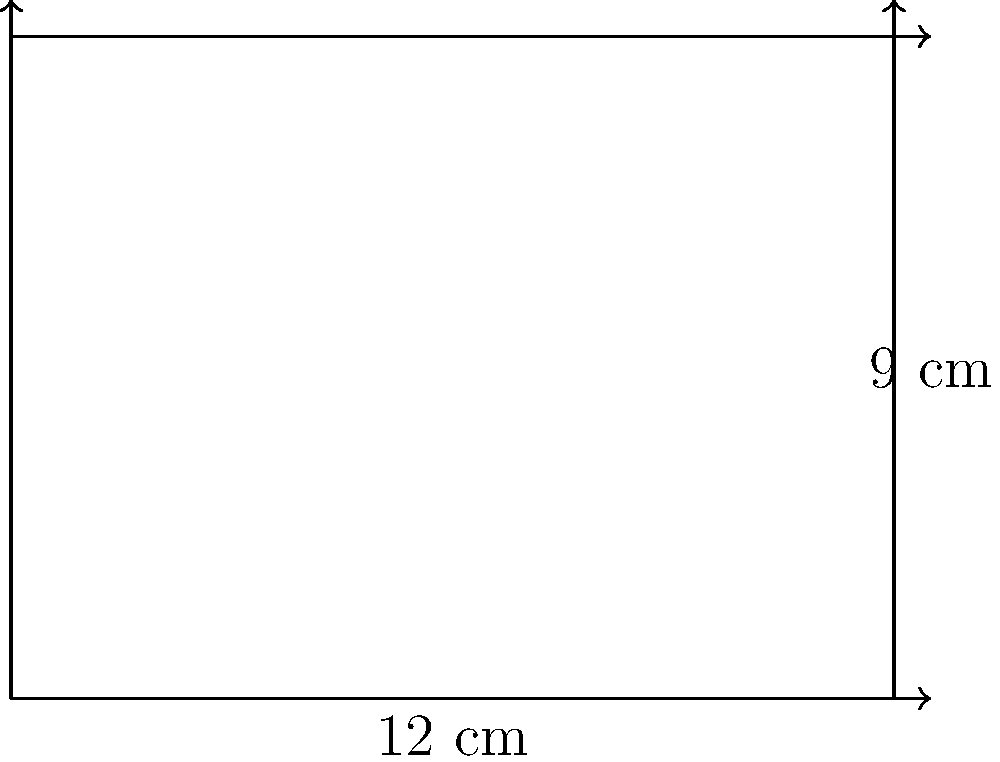As a literary editor negotiating your own book contracts, you're designing a hardcover edition. The book cover has rectangular dimensions of 12 cm by 9 cm. What is the area of the book cover in square centimeters? To calculate the area of a rectangle, we use the formula:

$$ A = l \times w $$

Where:
$A$ = Area
$l$ = Length
$w$ = Width

Given:
Length = 12 cm
Width = 9 cm

Step 1: Substitute the values into the formula
$$ A = 12 \text{ cm} \times 9 \text{ cm} $$

Step 2: Multiply
$$ A = 108 \text{ cm}^2 $$

Therefore, the area of the book cover is 108 square centimeters.
Answer: 108 cm² 